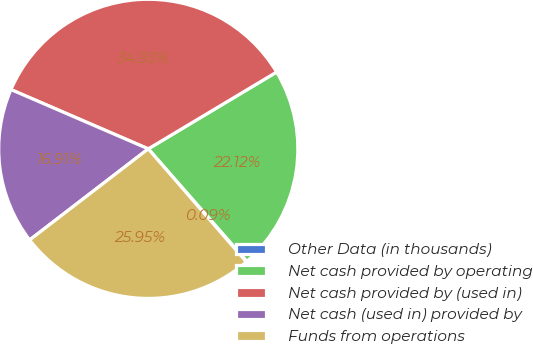<chart> <loc_0><loc_0><loc_500><loc_500><pie_chart><fcel>Other Data (in thousands)<fcel>Net cash provided by operating<fcel>Net cash provided by (used in)<fcel>Net cash (used in) provided by<fcel>Funds from operations<nl><fcel>0.09%<fcel>22.12%<fcel>34.93%<fcel>16.91%<fcel>25.95%<nl></chart> 